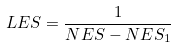<formula> <loc_0><loc_0><loc_500><loc_500>L E S = \frac { 1 } { N E S - N E S _ { 1 } }</formula> 